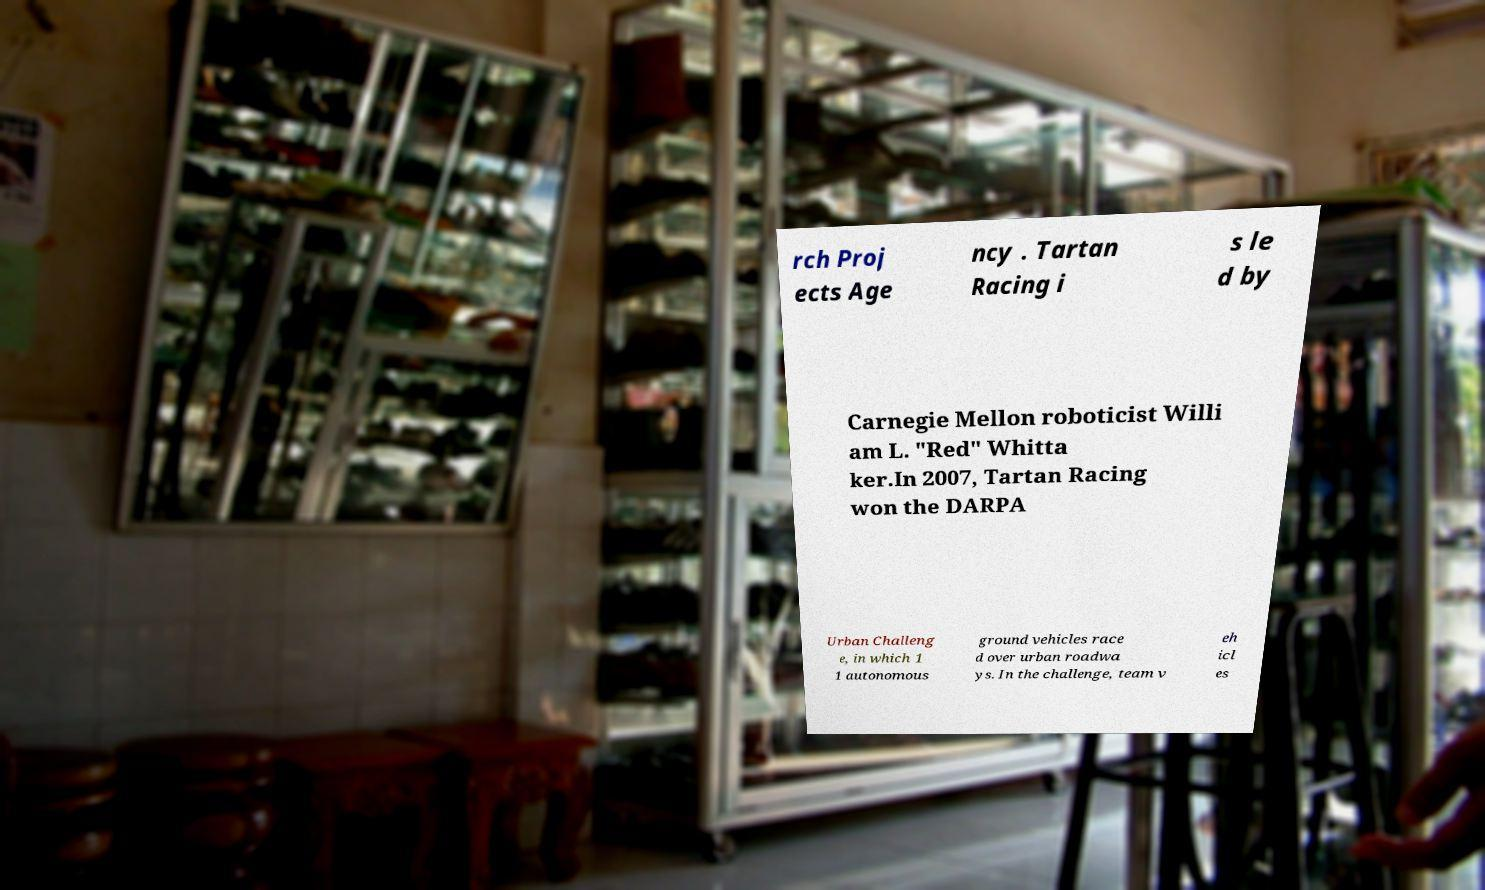Could you extract and type out the text from this image? rch Proj ects Age ncy . Tartan Racing i s le d by Carnegie Mellon roboticist Willi am L. "Red" Whitta ker.In 2007, Tartan Racing won the DARPA Urban Challeng e, in which 1 1 autonomous ground vehicles race d over urban roadwa ys. In the challenge, team v eh icl es 